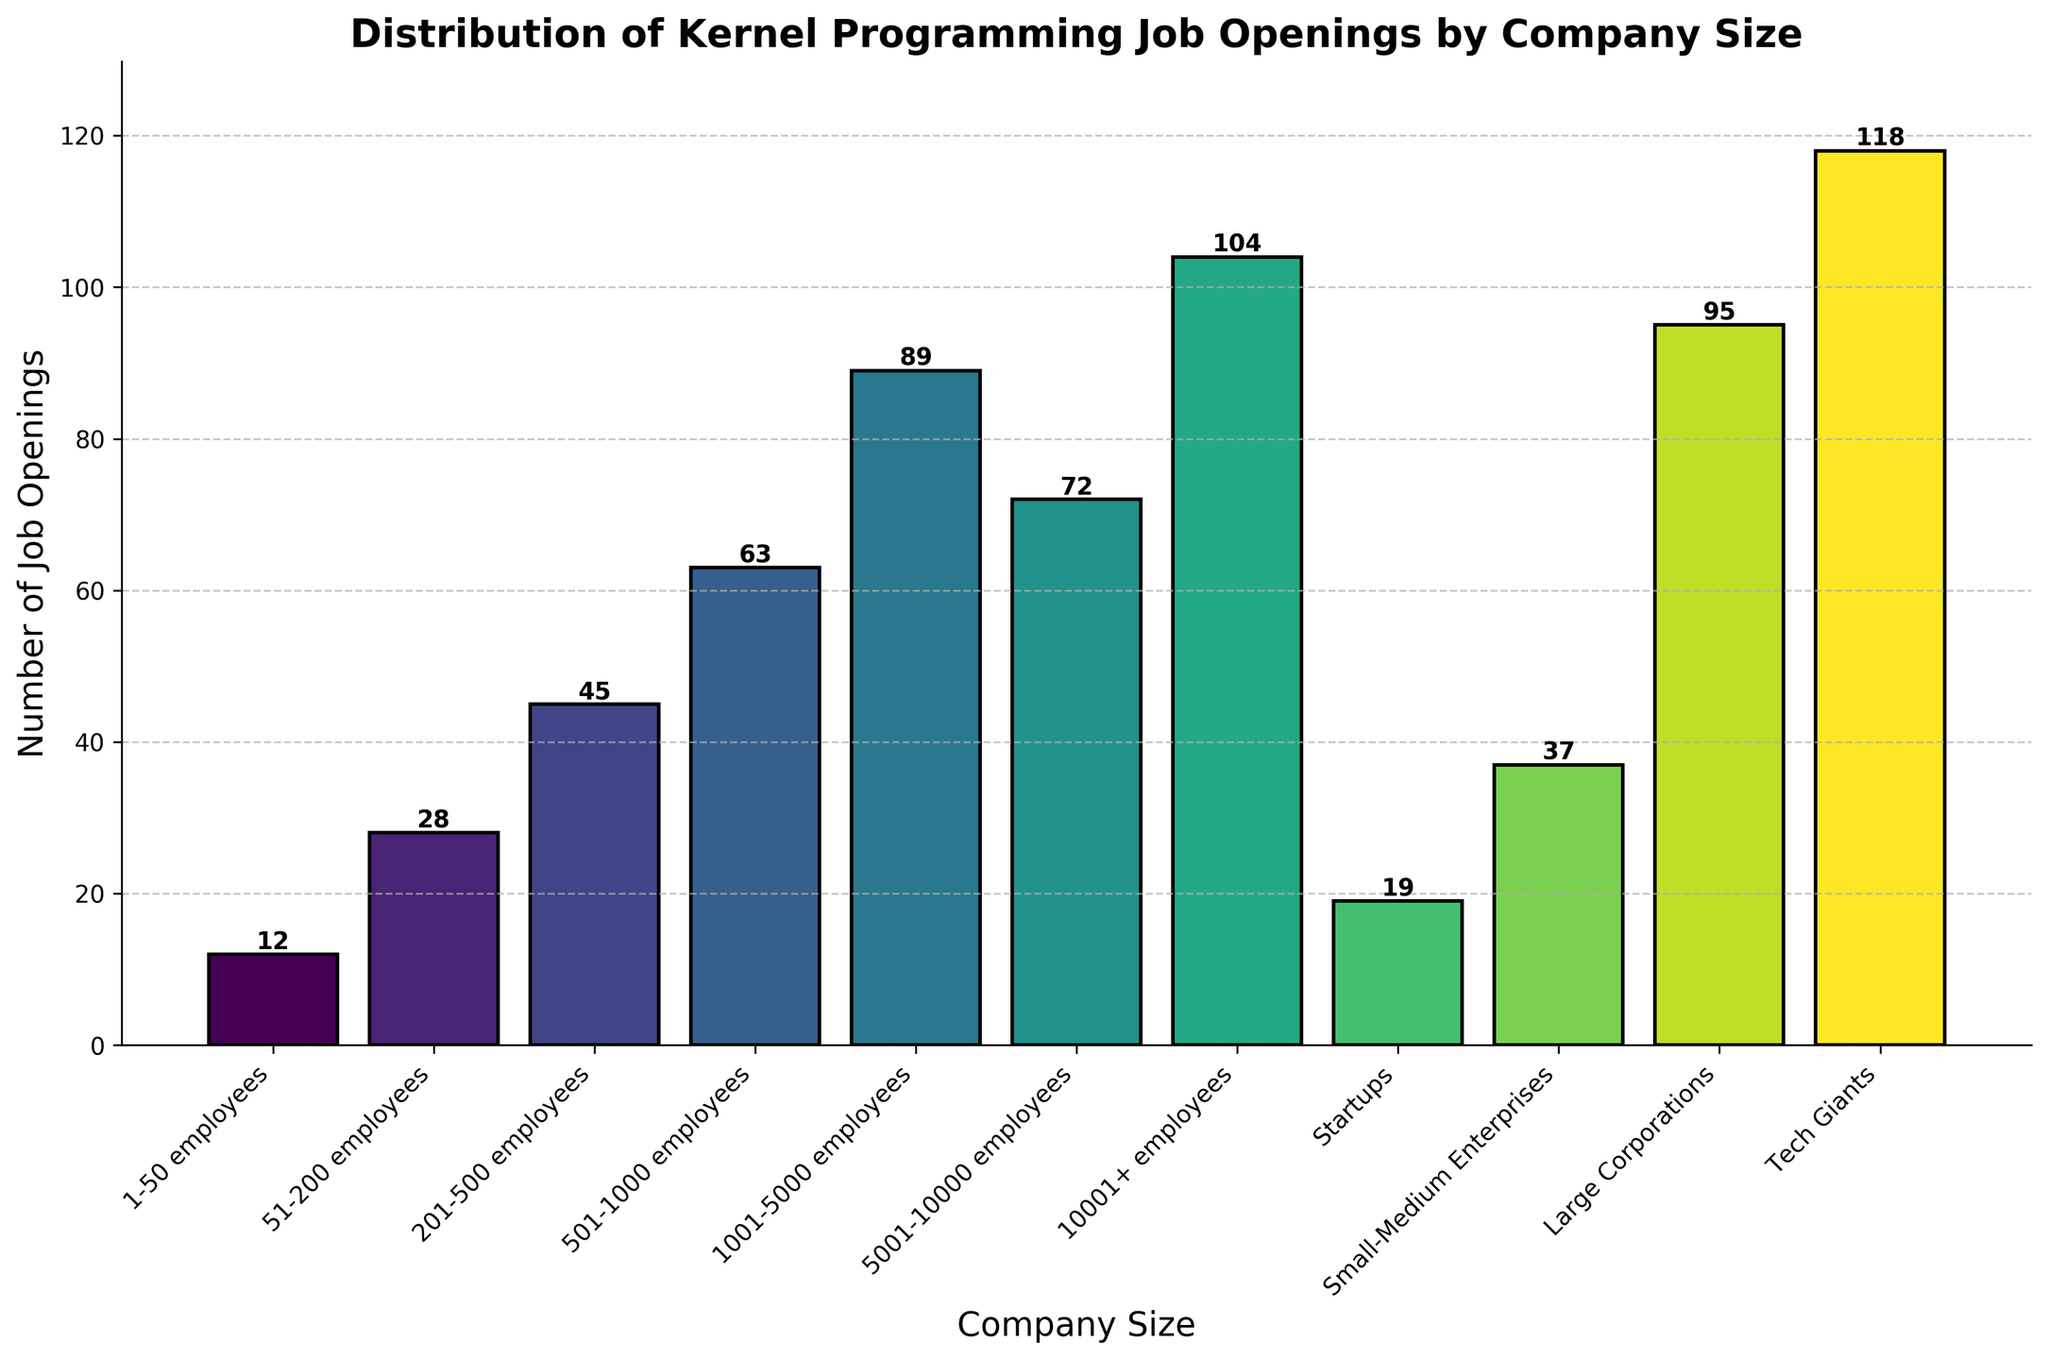What's the total number of job openings across all company sizes? Sum the number of job openings for each company size: 12 + 28 + 45 + 63 + 89 + 72 + 104 + 19 + 37 + 95 + 118 = 682
Answer: 682 Which company size has the highest number of kernel programming job openings? From the chart, "Tech Giants" have the tallest bar, indicating the highest number of job openings at 118.
Answer: Tech Giants What is the difference in the number of job openings between companies with 1001-5000 employees and those with 5001-10000 employees? The bar representing 1001-5000 employees has 89 job openings, and the one representing 5001-10000 employees has 72. The difference is 89 - 72 = 17.
Answer: 17 How many more job openings do large corporations have compared to startups? Large corporations have 95 job openings, and startups have 19. The difference is 95 - 19 = 76.
Answer: 76 What's the average number of job openings across the four largest company size categories (5001+ employees, Startups, Small-Medium Enterprises, Large Corporations, Tech Giants)? First, sum the job openings: 104 + 72 + 19 + 37 + 95 + 118 = 351. Then, divide by the number of categories (5): 351 / 5 = 70.2
Answer: 70.2 Which two company size categories have the closest number of job openings and what is the difference? The closest numbers are between companies with 201-500 employees (45) and small-medium enterprises (37). The difference is 45 - 37 = 8.
Answer: 201-500 employees and Small-Medium Enterprises; 8 Is the number of job openings in companies with 51-200 employees greater than the sum of those in companies with 1-50 employees and startups? Companies with 51-200 employees have 28 job openings. The sum of openings in companies with 1-50 employees and startups is 12 + 19 = 31, which is greater than 28.
Answer: No What is the range of job openings across all company sizes? The range is the difference between the maximum and minimum values: 118 (Tech Giants) - 12 (1-50 employees) = 106.
Answer: 106 Which company size category adds up to more job openings than the combined total of 501-1000 employees and startups? Calculate the sum for 501-1000 employees and startups: 63 + 19 = 82. Check the next higher categories: 1001-5000 employees = 89 openings.
Answer: 1001-5000 employees Are there more job openings in companies with 1001+ employees than in those with fewer than 1001 employees? Sum the openings for 1001+ employees (104 + 72 + 118) = 294. Sum the openings for <1001 employees (12 + 28 + 45 + 63 + 89) = 237. 294 is greater than 237.
Answer: Yes 